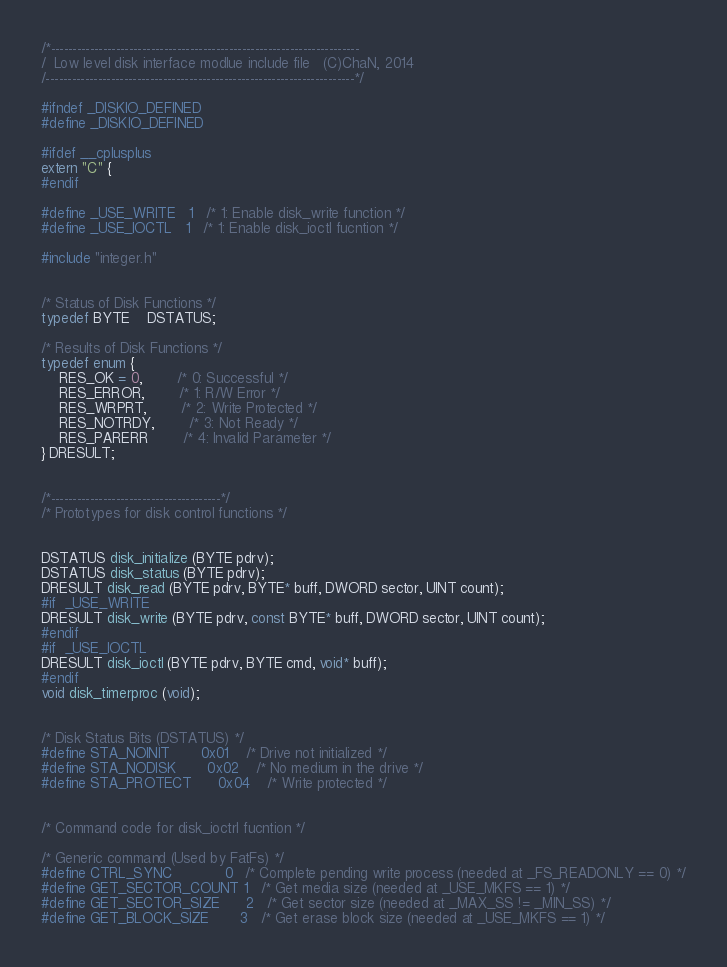Convert code to text. <code><loc_0><loc_0><loc_500><loc_500><_C_>/*-----------------------------------------------------------------------
/  Low level disk interface modlue include file   (C)ChaN, 2014
/-----------------------------------------------------------------------*/

#ifndef _DISKIO_DEFINED
#define _DISKIO_DEFINED

#ifdef __cplusplus
extern "C" {
#endif

#define _USE_WRITE	1	/* 1: Enable disk_write function */
#define _USE_IOCTL	1	/* 1: Enable disk_ioctl fucntion */

#include "integer.h"


/* Status of Disk Functions */
typedef BYTE	DSTATUS;

/* Results of Disk Functions */
typedef enum {
	RES_OK = 0,		/* 0: Successful */
	RES_ERROR,		/* 1: R/W Error */
	RES_WRPRT,		/* 2: Write Protected */
	RES_NOTRDY,		/* 3: Not Ready */
	RES_PARERR		/* 4: Invalid Parameter */
} DRESULT;


/*---------------------------------------*/
/* Prototypes for disk control functions */


DSTATUS disk_initialize (BYTE pdrv);
DSTATUS disk_status (BYTE pdrv);
DRESULT disk_read (BYTE pdrv, BYTE* buff, DWORD sector, UINT count);
#if	_USE_WRITE
DRESULT disk_write (BYTE pdrv, const BYTE* buff, DWORD sector, UINT count);
#endif
#if	_USE_IOCTL
DRESULT disk_ioctl (BYTE pdrv, BYTE cmd, void* buff);
#endif
void disk_timerproc (void);


/* Disk Status Bits (DSTATUS) */
#define STA_NOINIT		0x01	/* Drive not initialized */
#define STA_NODISK		0x02	/* No medium in the drive */
#define STA_PROTECT		0x04	/* Write protected */


/* Command code for disk_ioctrl fucntion */

/* Generic command (Used by FatFs) */
#define CTRL_SYNC			0	/* Complete pending write process (needed at _FS_READONLY == 0) */
#define GET_SECTOR_COUNT	1	/* Get media size (needed at _USE_MKFS == 1) */
#define GET_SECTOR_SIZE		2	/* Get sector size (needed at _MAX_SS != _MIN_SS) */
#define GET_BLOCK_SIZE		3	/* Get erase block size (needed at _USE_MKFS == 1) */</code> 